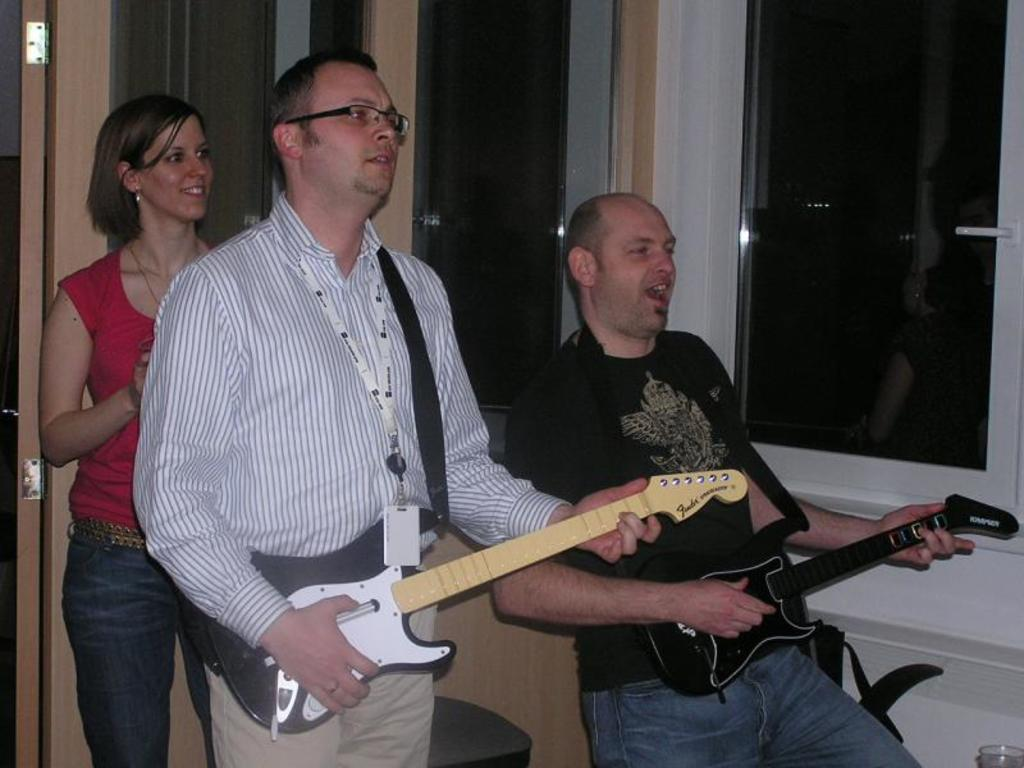How many people are in the image? There are three people in the image: two men and one woman. What are the men doing in the image? The men are playing guitar in the image. How are the men holding the guitars? The men are holding the guitars in their hands. What is the woman doing in the image? The woman is standing and smiling in the image. What type of arithmetic problem is the woman solving in the image? There is no arithmetic problem present in the image; the woman is simply standing and smiling. 